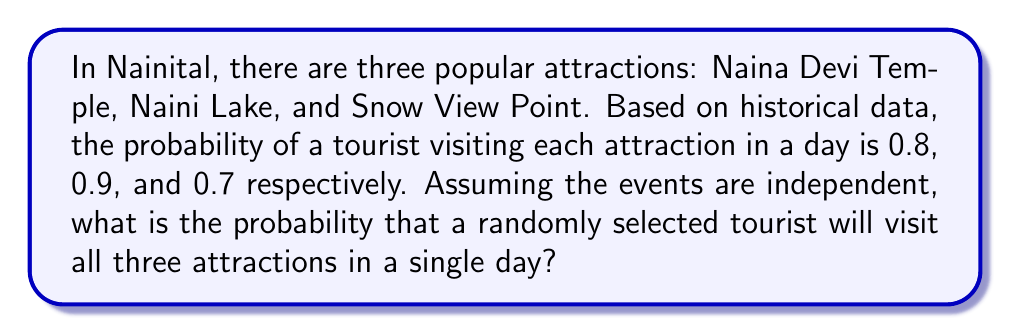Could you help me with this problem? Let's approach this step-by-step:

1) Let's define our events:
   A: Tourist visits Naina Devi Temple
   B: Tourist visits Naini Lake
   C: Tourist visits Snow View Point

2) We're given the following probabilities:
   P(A) = 0.8
   P(B) = 0.9
   P(C) = 0.7

3) We need to find the probability of all these events occurring together. Since the events are independent, we can multiply their individual probabilities:

   P(A and B and C) = P(A) × P(B) × P(C)

4) Let's substitute the values:

   P(A and B and C) = 0.8 × 0.9 × 0.7

5) Now, let's calculate:

   P(A and B and C) = 0.8 × 0.9 × 0.7 = 0.504

6) To convert to a percentage:

   0.504 × 100 = 50.4%

Therefore, the probability that a randomly selected tourist will visit all three attractions in a single day is 0.504 or 50.4%.
Answer: 0.504 or 50.4% 